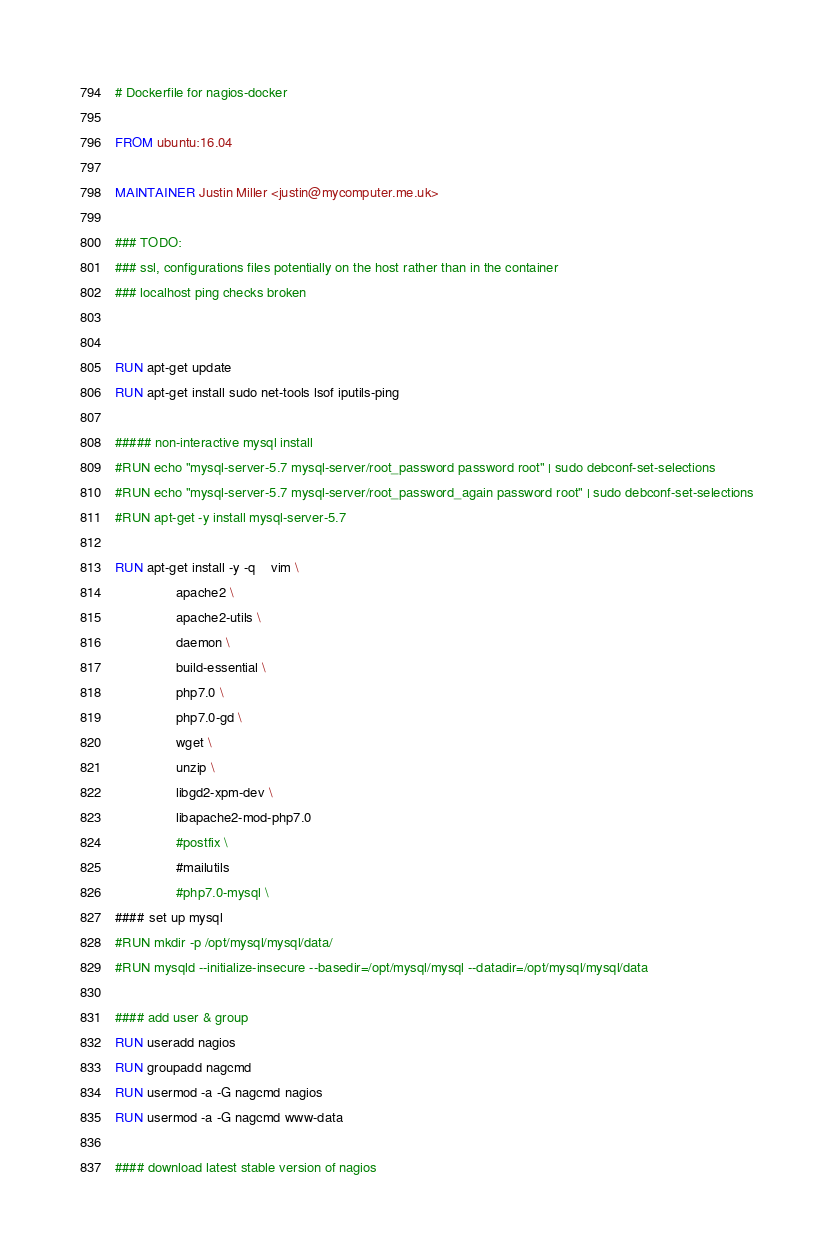Convert code to text. <code><loc_0><loc_0><loc_500><loc_500><_Dockerfile_># Dockerfile for nagios-docker

FROM ubuntu:16.04

MAINTAINER Justin Miller <justin@mycomputer.me.uk>

### TODO:
### ssl, configurations files potentially on the host rather than in the container
### localhost ping checks broken


RUN apt-get update
RUN apt-get install sudo net-tools lsof iputils-ping

##### non-interactive mysql install
#RUN echo "mysql-server-5.7 mysql-server/root_password password root" | sudo debconf-set-selections
#RUN echo "mysql-server-5.7 mysql-server/root_password_again password root" | sudo debconf-set-selections
#RUN apt-get -y install mysql-server-5.7

RUN apt-get install -y -q	vim \
				apache2 \
				apache2-utils \
				daemon \ 
				build-essential \
				php7.0 \
				php7.0-gd \
				wget \
				unzip \
				libgd2-xpm-dev \
				libapache2-mod-php7.0 
				#postfix \
				#mailutils 
				#php7.0-mysql \
#### set up mysql
#RUN mkdir -p /opt/mysql/mysql/data/
#RUN mysqld --initialize-insecure --basedir=/opt/mysql/mysql --datadir=/opt/mysql/mysql/data 

#### add user & group
RUN useradd nagios
RUN groupadd nagcmd
RUN usermod -a -G nagcmd nagios
RUN usermod -a -G nagcmd www-data

#### download latest stable version of nagios</code> 